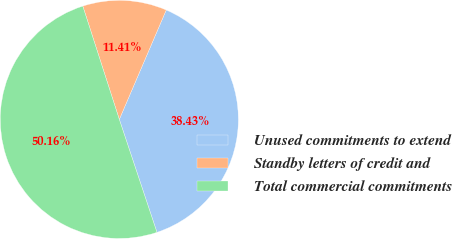Convert chart to OTSL. <chart><loc_0><loc_0><loc_500><loc_500><pie_chart><fcel>Unused commitments to extend<fcel>Standby letters of credit and<fcel>Total commercial commitments<nl><fcel>38.43%<fcel>11.41%<fcel>50.16%<nl></chart> 